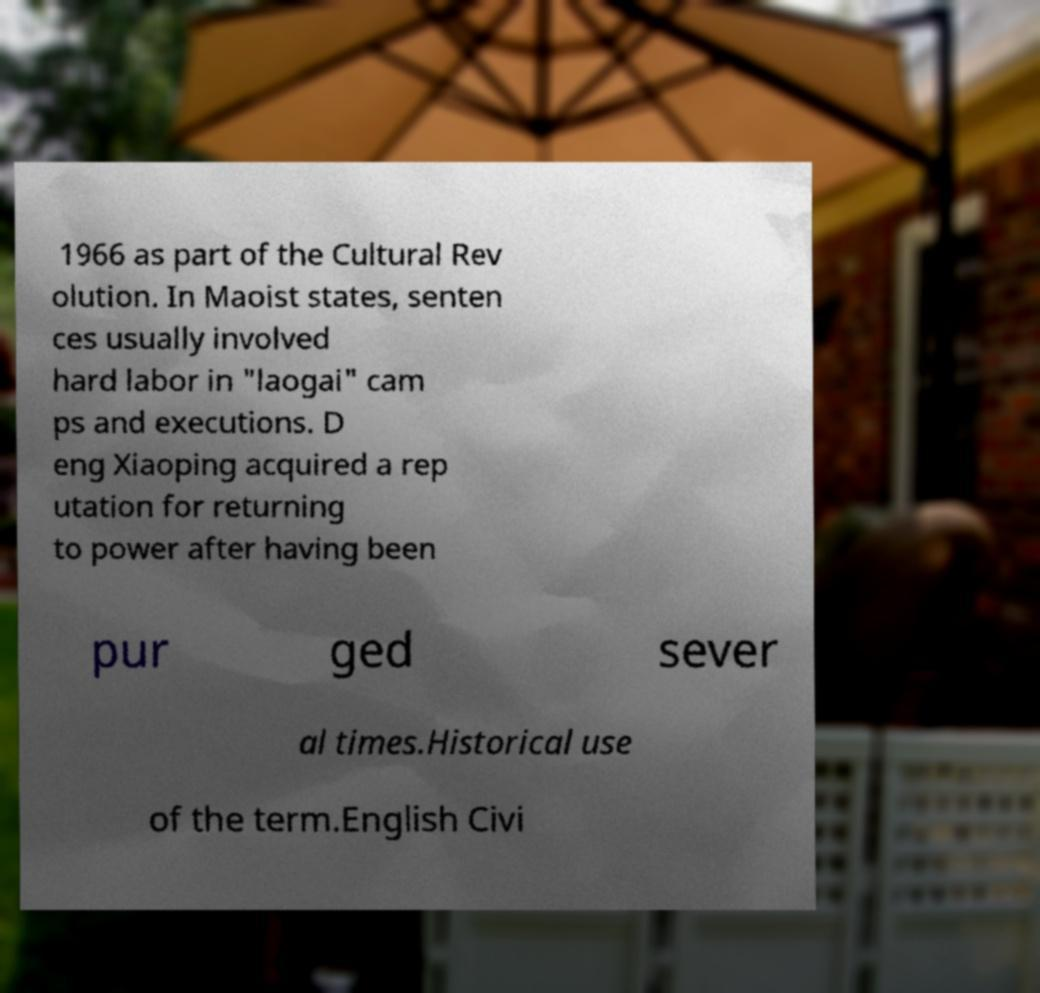There's text embedded in this image that I need extracted. Can you transcribe it verbatim? 1966 as part of the Cultural Rev olution. In Maoist states, senten ces usually involved hard labor in "laogai" cam ps and executions. D eng Xiaoping acquired a rep utation for returning to power after having been pur ged sever al times.Historical use of the term.English Civi 